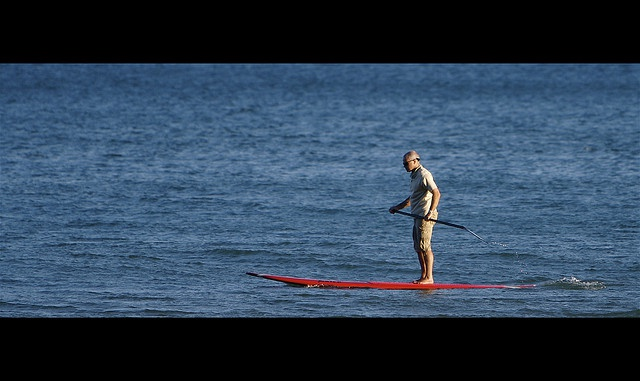Describe the objects in this image and their specific colors. I can see people in black, tan, gray, and beige tones and surfboard in black, brown, maroon, and gray tones in this image. 